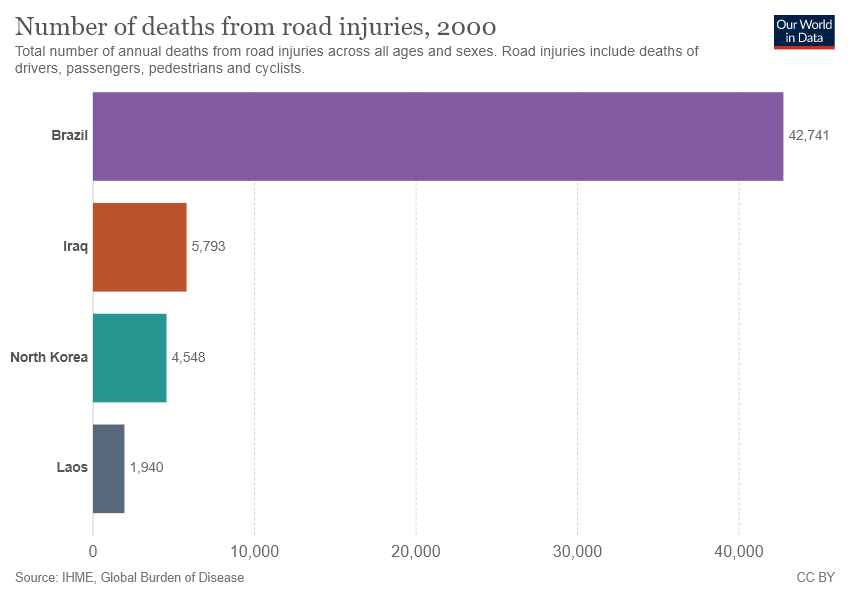Highlight a few significant elements in this photo. The value of the smallest bar is 1940. The difference between Iraq and North Korea is not greater than the value of Laos. 